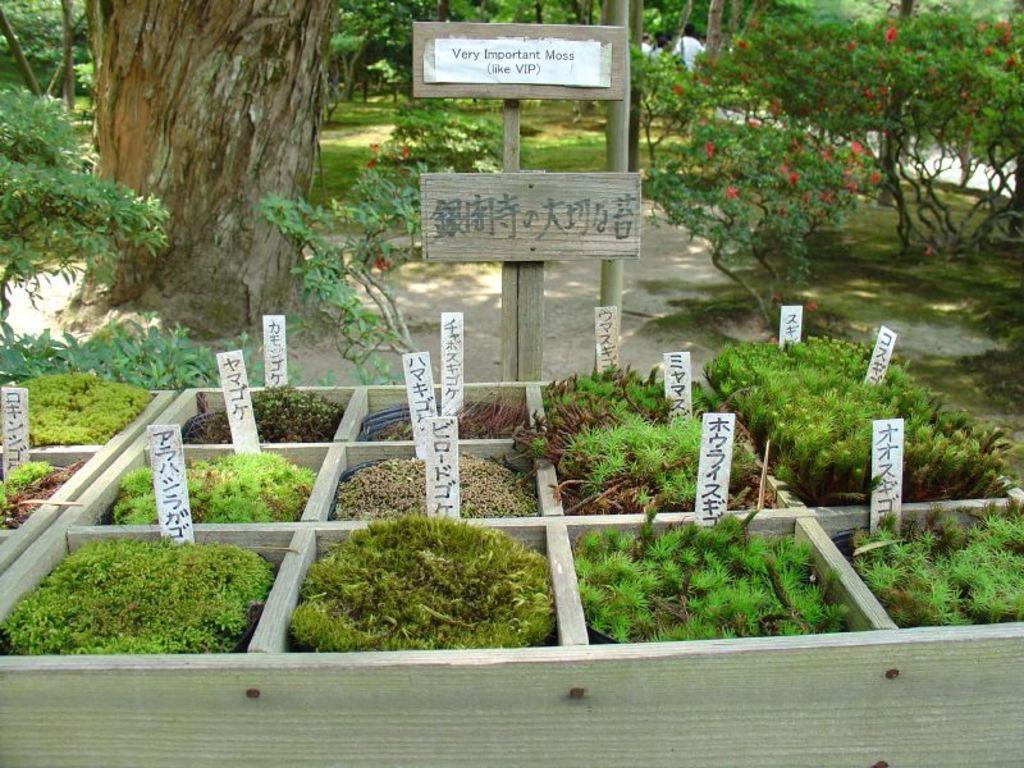What is depicted on the wooden blocks in the image? There are planets placed in wooden blocks in the image. What else can be seen in the image besides the wooden blocks? There are boards in the image. What type of natural environment is visible in the background of the image? There are trees visible in the background of the image. Can you tell me how many cats are sitting on the boards in the image? There are no cats present in the image; it features wooden blocks with planets and boards. What type of transport is visible in the image? There is no transport visible in the image. 